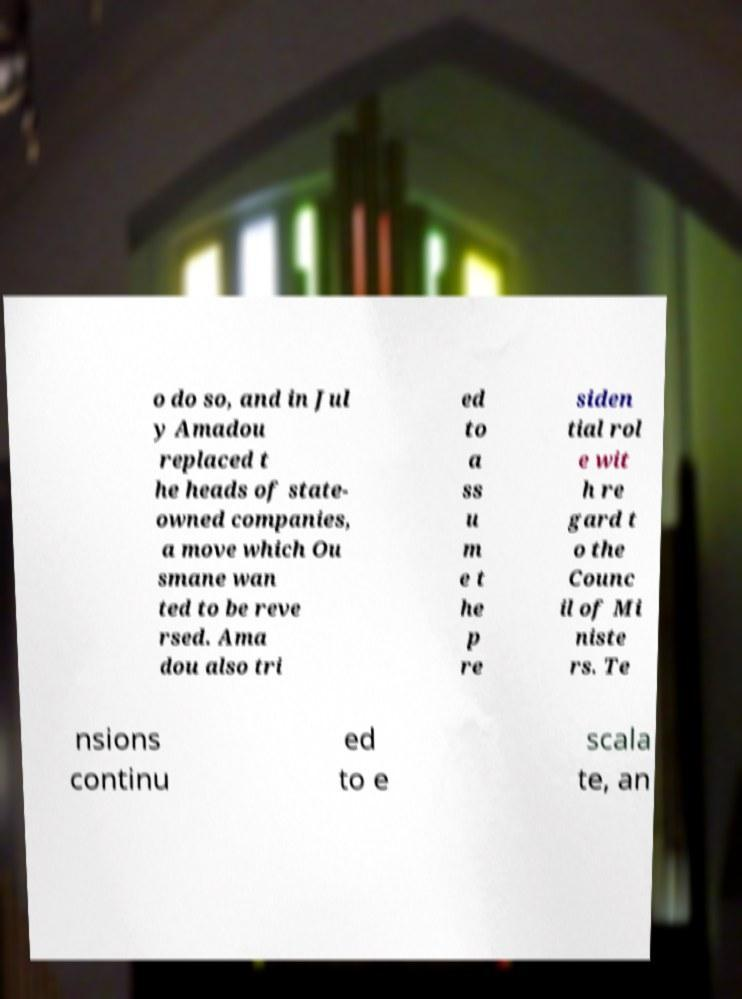Please read and relay the text visible in this image. What does it say? o do so, and in Jul y Amadou replaced t he heads of state- owned companies, a move which Ou smane wan ted to be reve rsed. Ama dou also tri ed to a ss u m e t he p re siden tial rol e wit h re gard t o the Counc il of Mi niste rs. Te nsions continu ed to e scala te, an 